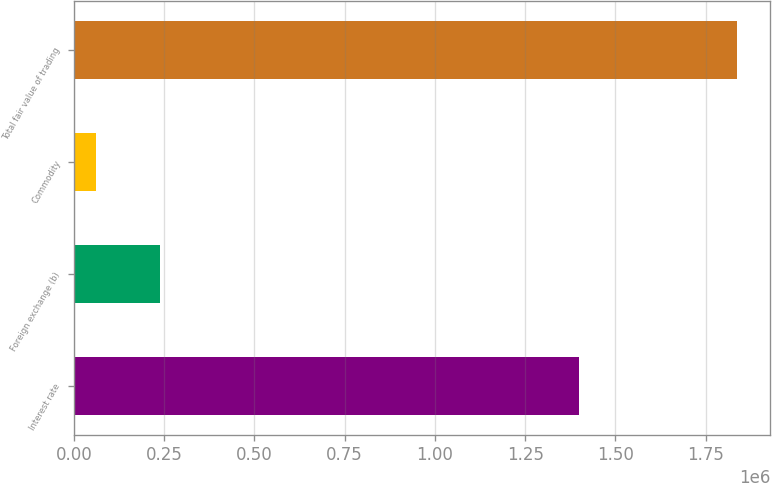Convert chart. <chart><loc_0><loc_0><loc_500><loc_500><bar_chart><fcel>Interest rate<fcel>Foreign exchange (b)<fcel>Commodity<fcel>Total fair value of trading<nl><fcel>1.39982e+06<fcel>237675<fcel>59944<fcel>1.83726e+06<nl></chart> 